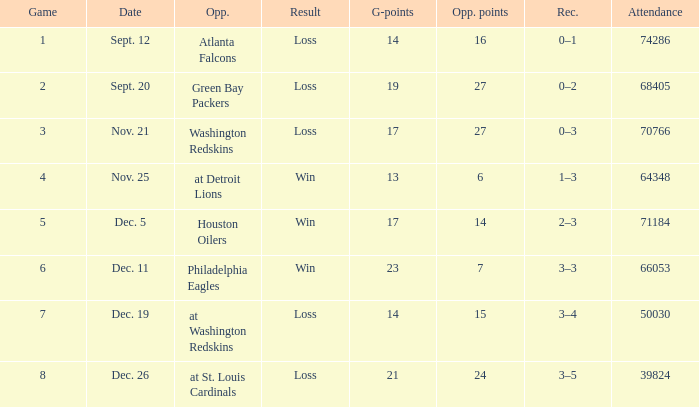What is the minimum number of opponents? 6.0. 